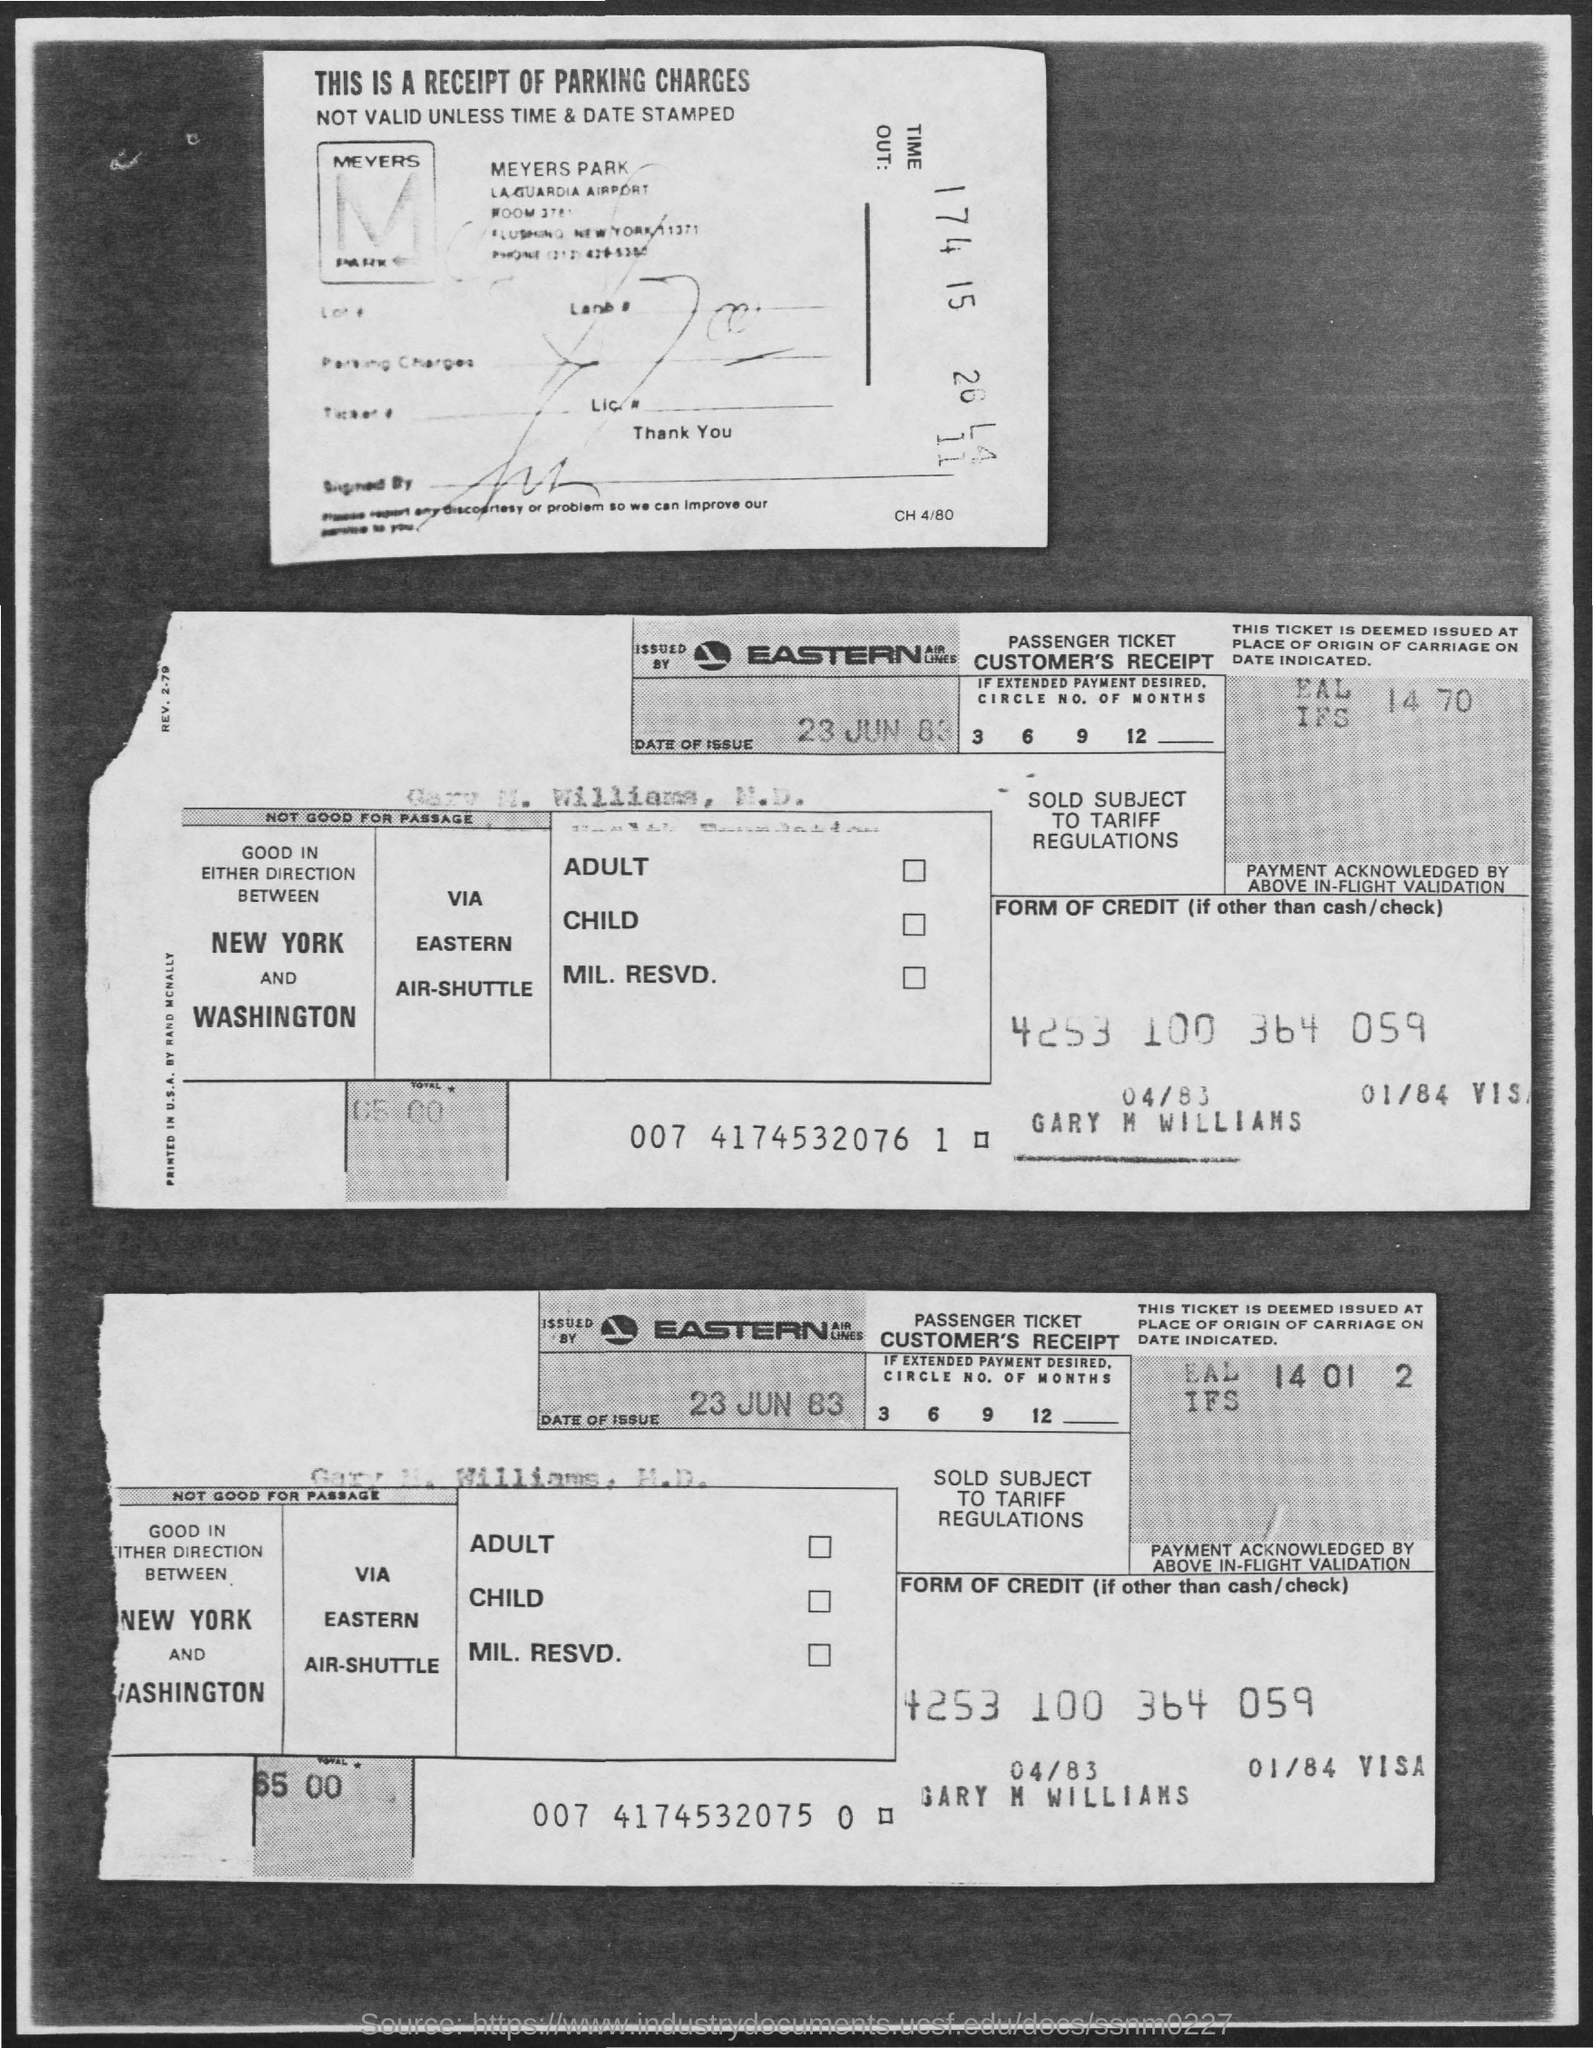Highlight a few significant elements in this photo. The total amount mentioned in the given form is 65,000. The date of issue mentioned in the given page is June 23, 1983. 